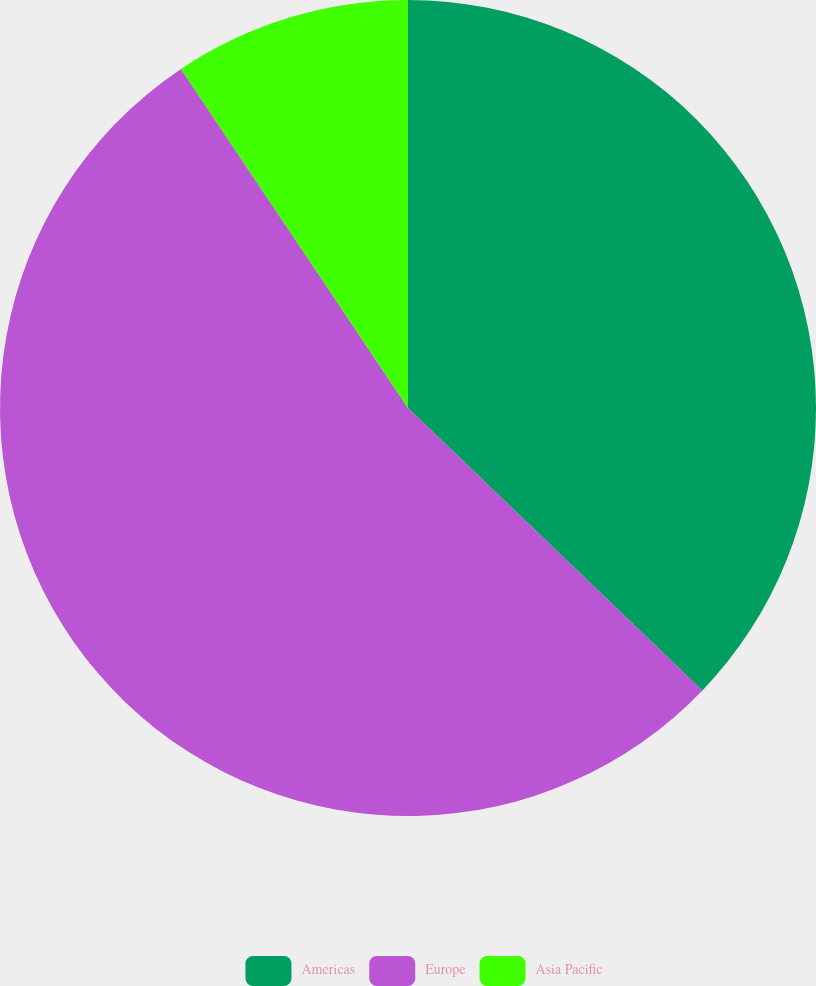Convert chart. <chart><loc_0><loc_0><loc_500><loc_500><pie_chart><fcel>Americas<fcel>Europe<fcel>Asia Pacific<nl><fcel>37.17%<fcel>53.44%<fcel>9.39%<nl></chart> 